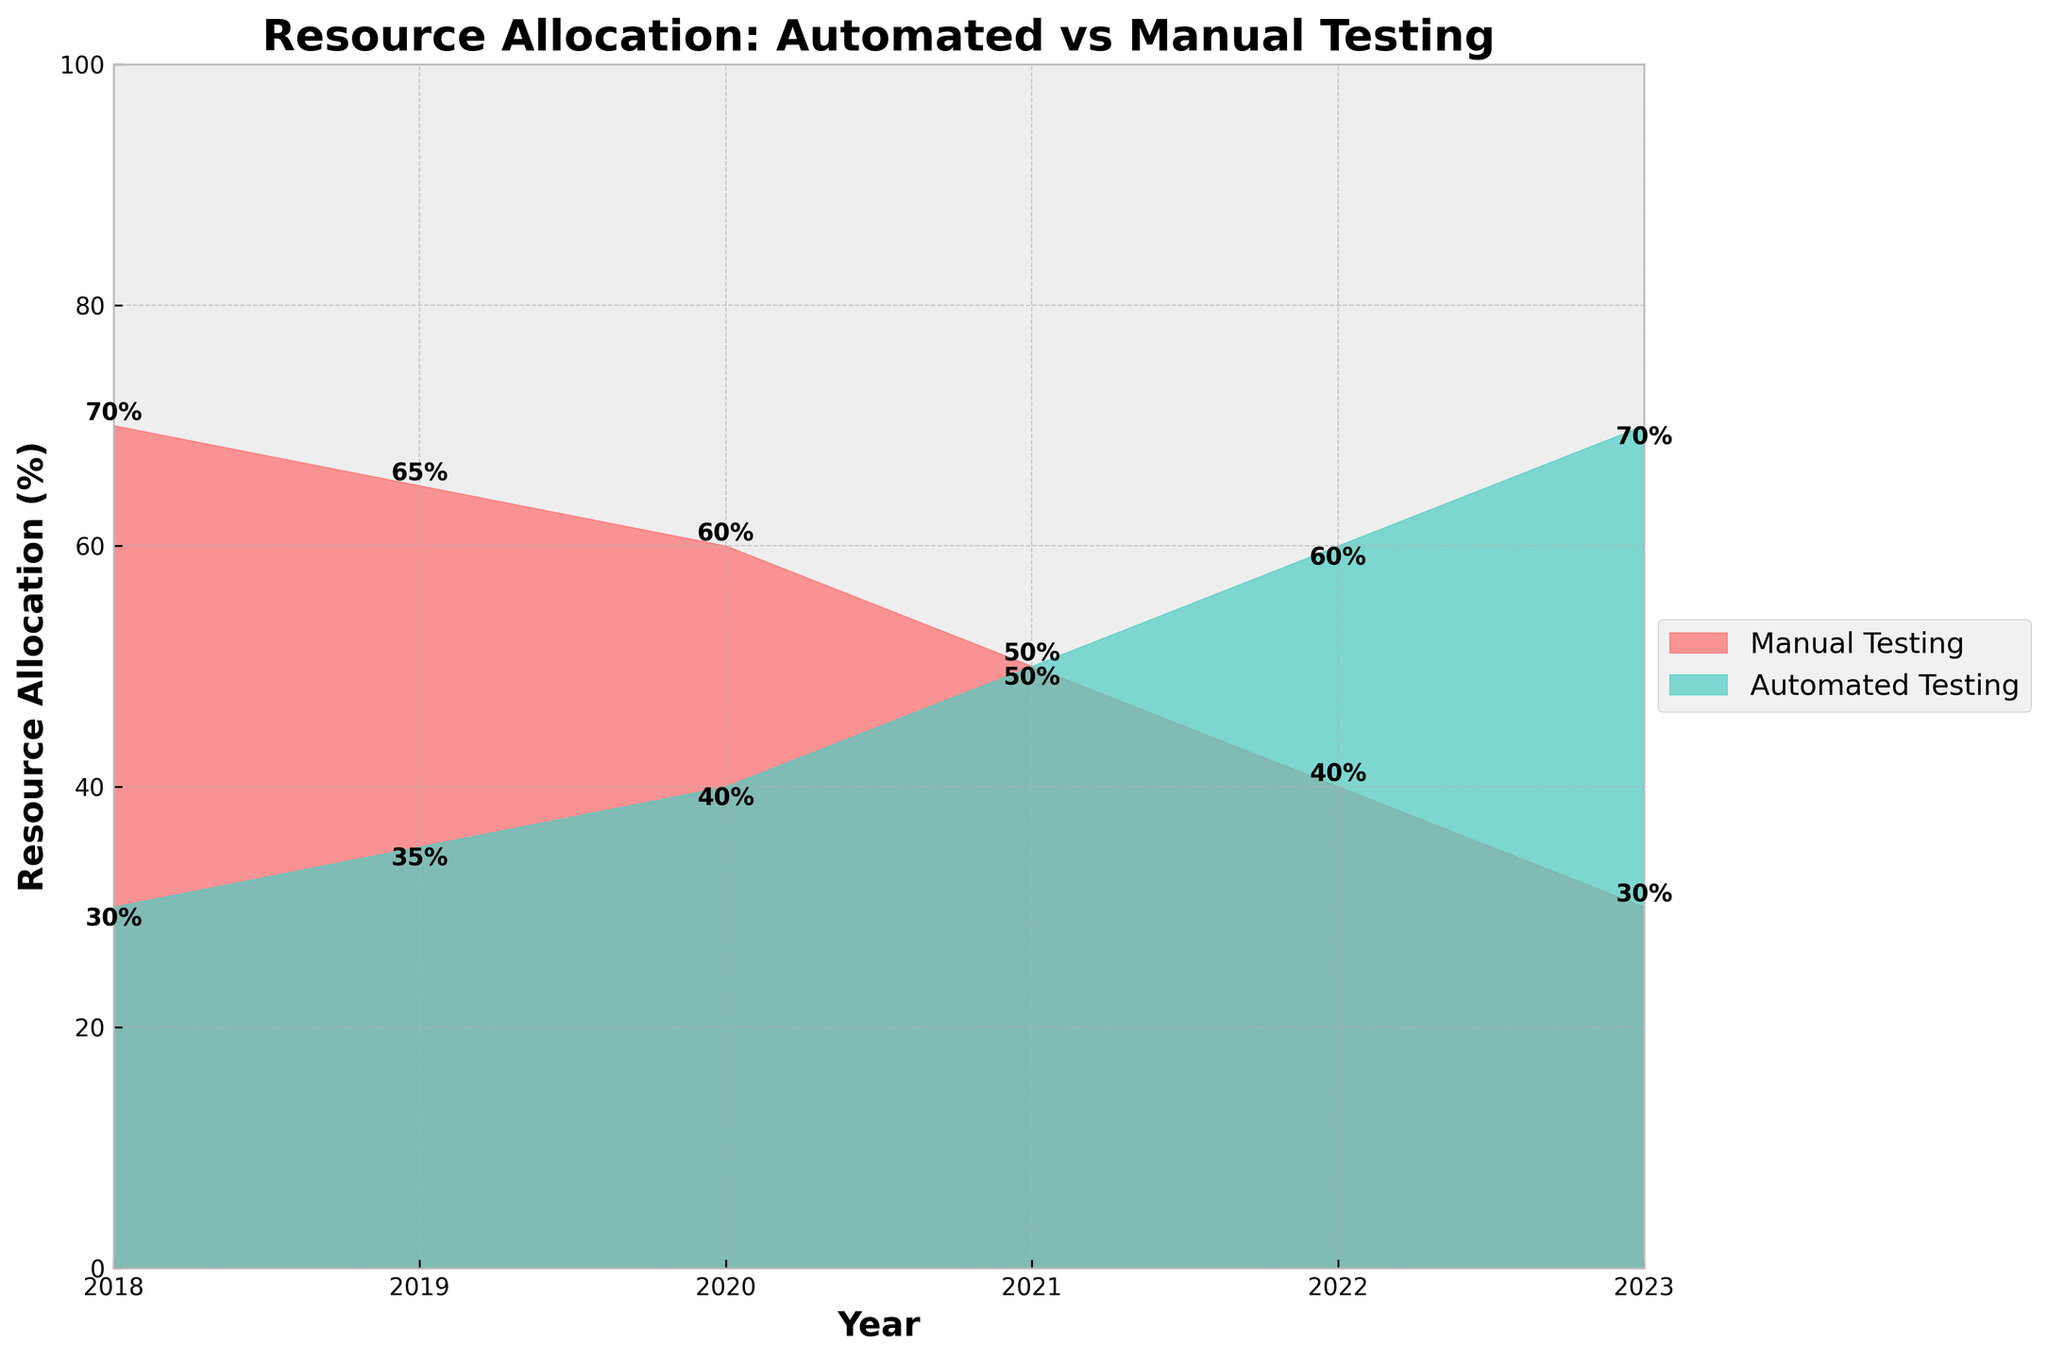What is the title of the figure? The title can be found at the top of the figure. It states the main subject represented by the data.
Answer: Resource Allocation: Automated vs Manual Testing Which testing type had more resources allocated in 2018? By looking at the height of the colored areas in 2018, the red area (representing Manual Testing) is larger than the turquoise area (representing Automated Testing).
Answer: Manual Testing How many years are displayed on the x-axis? The data points span from 2018 to 2023, so counting these years gives the number of years displayed.
Answer: 6 years What are the colors used for Manual Testing and Automated Testing? The color legend indicates that Manual Testing is represented by red and Automated Testing by turquoise.
Answer: Red for Manual Testing and Turquoise for Automated Testing What year did Automated Testing and Manual Testing have the same resource allocation? By observing the overlap in the colored areas, 2021 is the year when the two areas are equal.
Answer: 2021 How did the allocation for Manual Testing change from 2018 to 2023? The allocation decreased from 70% in 2018 to 30% in 2023.
Answer: Decreased By how much did the resources for Automated Testing increase between 2018 and 2023? The allocation for Automated Testing increased from 30% in 2018 to 70% in 2023. The difference can be calculated as 70% - 30%.
Answer: 40% Which year saw the steepest decline in Manual Testing resource allocation? By looking at the differences year by year, the biggest drop in the red area occurs between 2020 and 2021.
Answer: 2020 to 2021 Compare the resource allocation for Automated Testing in 2019 and 2022. Which year had a higher allocation? Comparing the turquoise areas in these years reveals that 2022 had a higher allocation than 2019.
Answer: 2022 What percentage of resources was allocated to Manual Testing in 2022? To find this, look directly at the label on the red area for 2022 which shows the allocation percentage.
Answer: 40% 